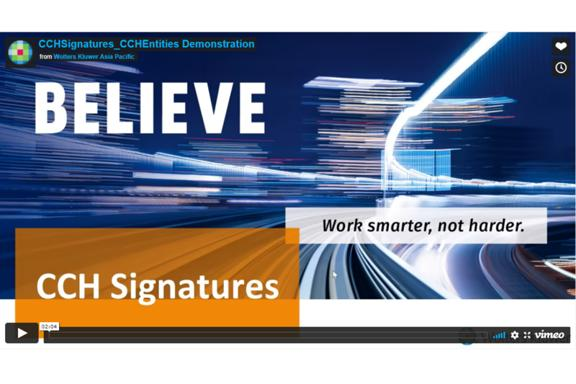What does the visual design of the image suggest about the corporate message? The dynamic design with fast-moving lights and bold text highlights innovation and forward-thinking, suggesting the company's focus on proactive and advanced solutions. 